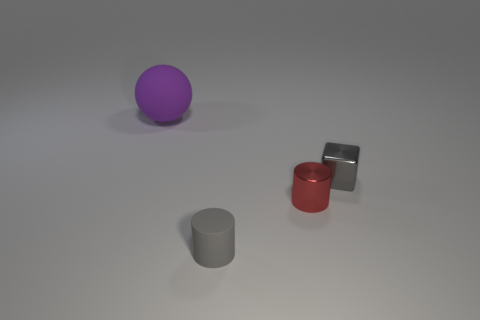What is the material of the tiny block that is the same color as the rubber cylinder?
Make the answer very short. Metal. What number of things are either cubes or tiny things left of the small gray shiny object?
Your response must be concise. 3. What material is the large purple ball?
Ensure brevity in your answer.  Rubber. There is a small gray thing that is the same shape as the small red metallic thing; what material is it?
Your answer should be compact. Rubber. There is a cylinder behind the tiny gray object that is in front of the small gray block; what color is it?
Offer a terse response. Red. How many metal objects are either brown blocks or large purple objects?
Offer a terse response. 0. Do the gray cylinder and the block have the same material?
Your answer should be very brief. No. What is the material of the thing left of the rubber object in front of the purple sphere?
Your answer should be very brief. Rubber. How many small objects are rubber cylinders or red rubber balls?
Your answer should be very brief. 1. The gray matte cylinder is what size?
Provide a short and direct response. Small. 